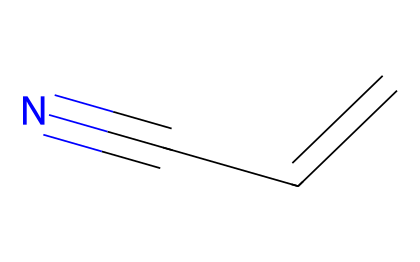What is the chemical name of this compound? The SMILES representation indicates the presence of a double bond (C=C) and a nitrile group (C#N), which identifies the compound as acrylonitrile.
Answer: acrylonitrile How many carbon atoms are in the molecular structure? By analyzing the SMILES notation "C=CC#N", we can see there are three carbon atoms (C) represented.
Answer: three What type of bond exists between the second carbon and the nitrogen? The representation shows a triple bond (indicated by "#") between the second carbon atom and the nitrogen atom (N), which is characteristic of nitriles.
Answer: triple What functional group is present in this chemical? The presence of the C#N notation indicates that this molecule contains a nitrile functional group, recognized by the carbon-nitrogen triple bond.
Answer: nitrile How many total bonds are there in the molecule? The molecule has one double bond (C=C) and one triple bond (C#N), totaling four bonds overall: 1 double bond + 1 triple bond = 4 bonds.
Answer: four Does this compound belong to alkenes? This compound has a double bond between carbon atoms; however, it also contains a nitrile group, which makes it a nitrile and not purely an alkene.
Answer: no 